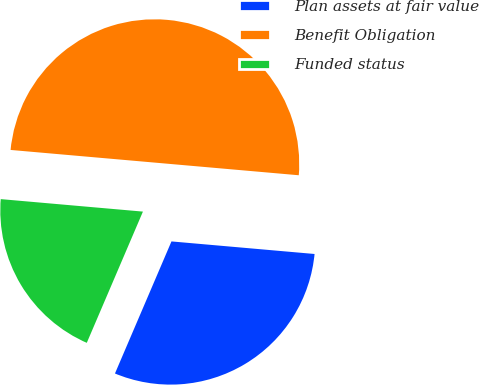<chart> <loc_0><loc_0><loc_500><loc_500><pie_chart><fcel>Plan assets at fair value<fcel>Benefit Obligation<fcel>Funded status<nl><fcel>30.04%<fcel>50.0%<fcel>19.96%<nl></chart> 